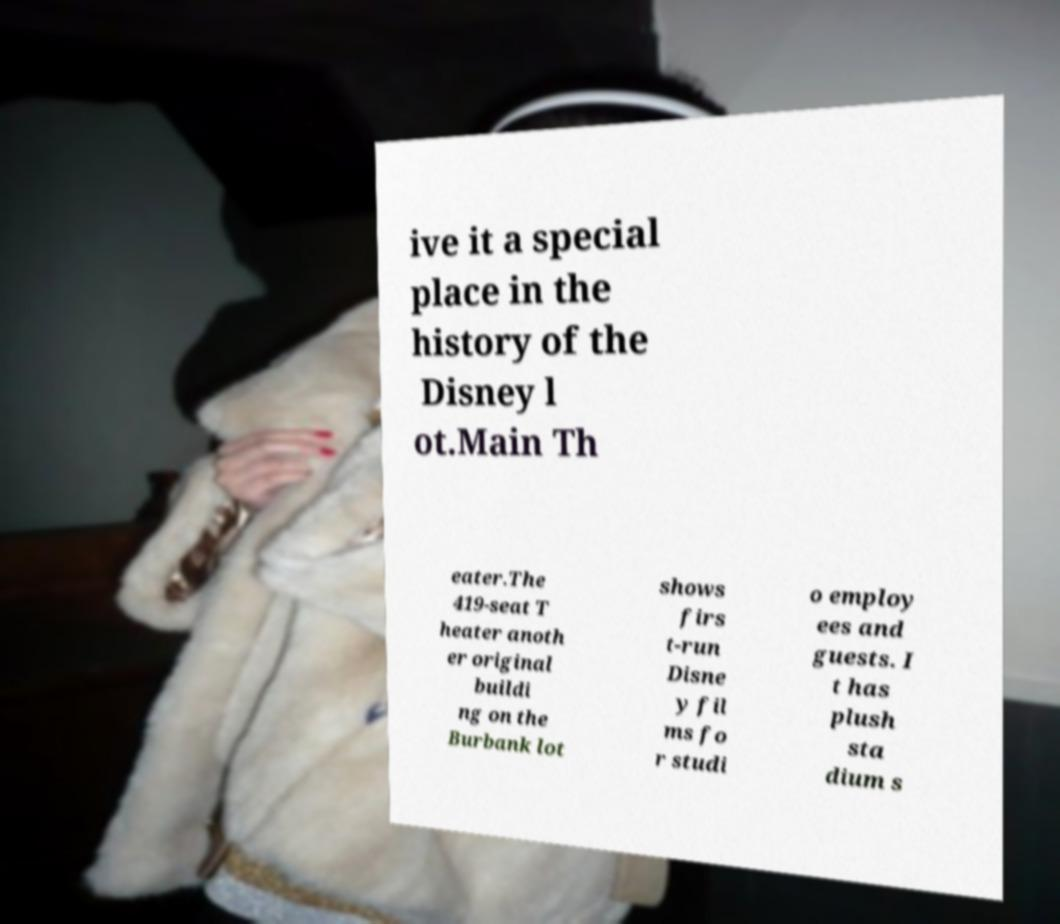Can you read and provide the text displayed in the image?This photo seems to have some interesting text. Can you extract and type it out for me? ive it a special place in the history of the Disney l ot.Main Th eater.The 419-seat T heater anoth er original buildi ng on the Burbank lot shows firs t-run Disne y fil ms fo r studi o employ ees and guests. I t has plush sta dium s 